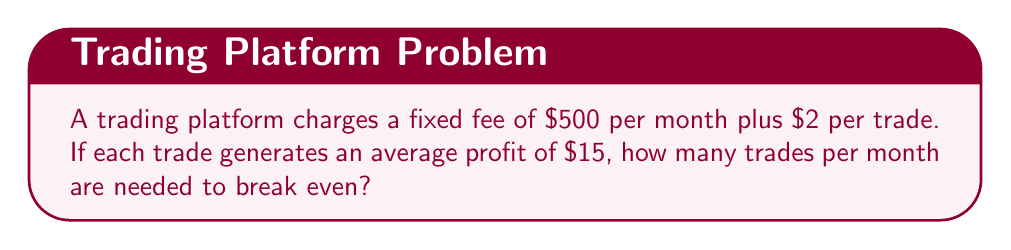Show me your answer to this math problem. To solve for the break-even point, we need to find the number of trades where the total revenue equals the total cost.

Let $x$ be the number of trades.

1. Set up the equation:
   Total Revenue = Total Cost
   $15x = 500 + 2x$

2. Subtract $2x$ from both sides:
   $13x = 500$

3. Divide both sides by 13:
   $x = \frac{500}{13} \approx 38.46$

4. Since we can't have a fractional number of trades, we round up to the next whole number.

Therefore, 39 trades are needed to break even.

To verify:
Revenue: $39 \times $15 = $585
Cost: $500 + (39 \times $2) = $578
Profit: $585 - $578 = $7

This confirms that 39 trades result in a small profit, while 38 trades would result in a loss.
Answer: 39 trades 